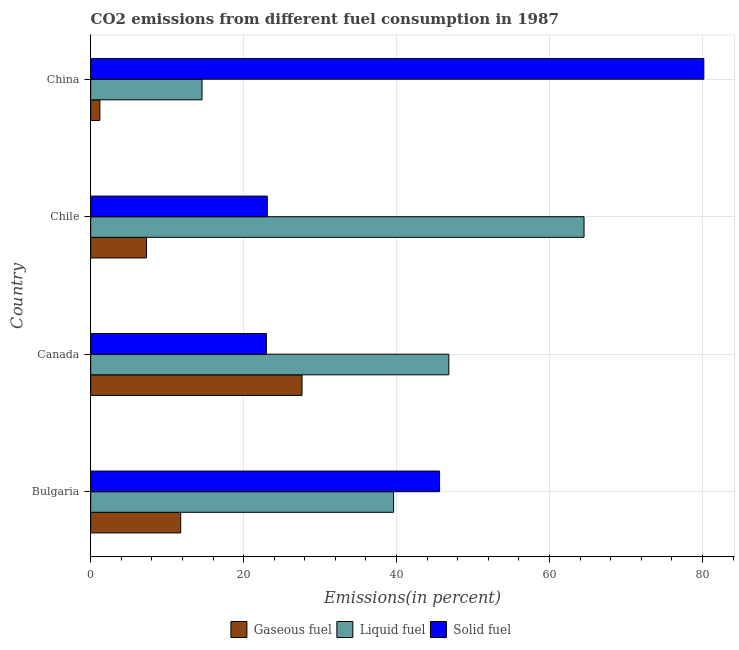Are the number of bars on each tick of the Y-axis equal?
Provide a succinct answer. Yes. How many bars are there on the 2nd tick from the top?
Give a very brief answer. 3. In how many cases, is the number of bars for a given country not equal to the number of legend labels?
Make the answer very short. 0. What is the percentage of solid fuel emission in China?
Provide a succinct answer. 80.18. Across all countries, what is the maximum percentage of solid fuel emission?
Offer a terse response. 80.18. Across all countries, what is the minimum percentage of liquid fuel emission?
Keep it short and to the point. 14.56. In which country was the percentage of solid fuel emission minimum?
Ensure brevity in your answer.  Canada. What is the total percentage of solid fuel emission in the graph?
Offer a terse response. 171.88. What is the difference between the percentage of gaseous fuel emission in Bulgaria and that in Chile?
Provide a short and direct response. 4.48. What is the difference between the percentage of solid fuel emission in China and the percentage of liquid fuel emission in Chile?
Provide a succinct answer. 15.66. What is the average percentage of liquid fuel emission per country?
Give a very brief answer. 41.38. What is the difference between the percentage of gaseous fuel emission and percentage of liquid fuel emission in Canada?
Keep it short and to the point. -19.2. In how many countries, is the percentage of liquid fuel emission greater than 32 %?
Provide a succinct answer. 3. What is the ratio of the percentage of gaseous fuel emission in Bulgaria to that in Chile?
Ensure brevity in your answer.  1.61. Is the percentage of solid fuel emission in Canada less than that in Chile?
Offer a terse response. Yes. What is the difference between the highest and the second highest percentage of gaseous fuel emission?
Provide a succinct answer. 15.86. What is the difference between the highest and the lowest percentage of solid fuel emission?
Keep it short and to the point. 57.2. Is the sum of the percentage of liquid fuel emission in Bulgaria and Chile greater than the maximum percentage of gaseous fuel emission across all countries?
Provide a short and direct response. Yes. What does the 2nd bar from the top in Chile represents?
Keep it short and to the point. Liquid fuel. What does the 2nd bar from the bottom in Chile represents?
Make the answer very short. Liquid fuel. How many bars are there?
Offer a terse response. 12. Are all the bars in the graph horizontal?
Provide a succinct answer. Yes. What is the difference between two consecutive major ticks on the X-axis?
Give a very brief answer. 20. What is the title of the graph?
Your response must be concise. CO2 emissions from different fuel consumption in 1987. What is the label or title of the X-axis?
Your response must be concise. Emissions(in percent). What is the label or title of the Y-axis?
Make the answer very short. Country. What is the Emissions(in percent) of Gaseous fuel in Bulgaria?
Provide a short and direct response. 11.78. What is the Emissions(in percent) in Liquid fuel in Bulgaria?
Your answer should be very brief. 39.61. What is the Emissions(in percent) of Solid fuel in Bulgaria?
Give a very brief answer. 45.62. What is the Emissions(in percent) of Gaseous fuel in Canada?
Make the answer very short. 27.64. What is the Emissions(in percent) in Liquid fuel in Canada?
Ensure brevity in your answer.  46.84. What is the Emissions(in percent) of Solid fuel in Canada?
Make the answer very short. 22.98. What is the Emissions(in percent) in Gaseous fuel in Chile?
Your answer should be compact. 7.29. What is the Emissions(in percent) in Liquid fuel in Chile?
Your answer should be compact. 64.52. What is the Emissions(in percent) of Solid fuel in Chile?
Make the answer very short. 23.1. What is the Emissions(in percent) in Gaseous fuel in China?
Make the answer very short. 1.2. What is the Emissions(in percent) of Liquid fuel in China?
Your response must be concise. 14.56. What is the Emissions(in percent) in Solid fuel in China?
Keep it short and to the point. 80.18. Across all countries, what is the maximum Emissions(in percent) of Gaseous fuel?
Offer a terse response. 27.64. Across all countries, what is the maximum Emissions(in percent) of Liquid fuel?
Keep it short and to the point. 64.52. Across all countries, what is the maximum Emissions(in percent) of Solid fuel?
Provide a succinct answer. 80.18. Across all countries, what is the minimum Emissions(in percent) of Gaseous fuel?
Keep it short and to the point. 1.2. Across all countries, what is the minimum Emissions(in percent) of Liquid fuel?
Your response must be concise. 14.56. Across all countries, what is the minimum Emissions(in percent) in Solid fuel?
Ensure brevity in your answer.  22.98. What is the total Emissions(in percent) in Gaseous fuel in the graph?
Offer a terse response. 47.91. What is the total Emissions(in percent) in Liquid fuel in the graph?
Offer a terse response. 165.53. What is the total Emissions(in percent) in Solid fuel in the graph?
Make the answer very short. 171.88. What is the difference between the Emissions(in percent) in Gaseous fuel in Bulgaria and that in Canada?
Offer a very short reply. -15.86. What is the difference between the Emissions(in percent) in Liquid fuel in Bulgaria and that in Canada?
Keep it short and to the point. -7.22. What is the difference between the Emissions(in percent) in Solid fuel in Bulgaria and that in Canada?
Give a very brief answer. 22.65. What is the difference between the Emissions(in percent) of Gaseous fuel in Bulgaria and that in Chile?
Ensure brevity in your answer.  4.48. What is the difference between the Emissions(in percent) of Liquid fuel in Bulgaria and that in Chile?
Provide a short and direct response. -24.9. What is the difference between the Emissions(in percent) of Solid fuel in Bulgaria and that in Chile?
Your answer should be compact. 22.53. What is the difference between the Emissions(in percent) of Gaseous fuel in Bulgaria and that in China?
Offer a terse response. 10.57. What is the difference between the Emissions(in percent) in Liquid fuel in Bulgaria and that in China?
Your answer should be compact. 25.05. What is the difference between the Emissions(in percent) in Solid fuel in Bulgaria and that in China?
Provide a short and direct response. -34.55. What is the difference between the Emissions(in percent) of Gaseous fuel in Canada and that in Chile?
Give a very brief answer. 20.34. What is the difference between the Emissions(in percent) in Liquid fuel in Canada and that in Chile?
Your response must be concise. -17.68. What is the difference between the Emissions(in percent) in Solid fuel in Canada and that in Chile?
Provide a succinct answer. -0.12. What is the difference between the Emissions(in percent) in Gaseous fuel in Canada and that in China?
Keep it short and to the point. 26.43. What is the difference between the Emissions(in percent) of Liquid fuel in Canada and that in China?
Offer a terse response. 32.27. What is the difference between the Emissions(in percent) of Solid fuel in Canada and that in China?
Your response must be concise. -57.2. What is the difference between the Emissions(in percent) in Gaseous fuel in Chile and that in China?
Your answer should be very brief. 6.09. What is the difference between the Emissions(in percent) of Liquid fuel in Chile and that in China?
Ensure brevity in your answer.  49.95. What is the difference between the Emissions(in percent) in Solid fuel in Chile and that in China?
Provide a succinct answer. -57.08. What is the difference between the Emissions(in percent) in Gaseous fuel in Bulgaria and the Emissions(in percent) in Liquid fuel in Canada?
Provide a succinct answer. -35.06. What is the difference between the Emissions(in percent) of Gaseous fuel in Bulgaria and the Emissions(in percent) of Solid fuel in Canada?
Provide a succinct answer. -11.2. What is the difference between the Emissions(in percent) in Liquid fuel in Bulgaria and the Emissions(in percent) in Solid fuel in Canada?
Keep it short and to the point. 16.64. What is the difference between the Emissions(in percent) of Gaseous fuel in Bulgaria and the Emissions(in percent) of Liquid fuel in Chile?
Provide a succinct answer. -52.74. What is the difference between the Emissions(in percent) in Gaseous fuel in Bulgaria and the Emissions(in percent) in Solid fuel in Chile?
Offer a terse response. -11.32. What is the difference between the Emissions(in percent) of Liquid fuel in Bulgaria and the Emissions(in percent) of Solid fuel in Chile?
Provide a succinct answer. 16.52. What is the difference between the Emissions(in percent) in Gaseous fuel in Bulgaria and the Emissions(in percent) in Liquid fuel in China?
Offer a terse response. -2.79. What is the difference between the Emissions(in percent) of Gaseous fuel in Bulgaria and the Emissions(in percent) of Solid fuel in China?
Your answer should be compact. -68.4. What is the difference between the Emissions(in percent) in Liquid fuel in Bulgaria and the Emissions(in percent) in Solid fuel in China?
Offer a very short reply. -40.57. What is the difference between the Emissions(in percent) in Gaseous fuel in Canada and the Emissions(in percent) in Liquid fuel in Chile?
Provide a succinct answer. -36.88. What is the difference between the Emissions(in percent) of Gaseous fuel in Canada and the Emissions(in percent) of Solid fuel in Chile?
Keep it short and to the point. 4.54. What is the difference between the Emissions(in percent) of Liquid fuel in Canada and the Emissions(in percent) of Solid fuel in Chile?
Your answer should be very brief. 23.74. What is the difference between the Emissions(in percent) in Gaseous fuel in Canada and the Emissions(in percent) in Liquid fuel in China?
Your response must be concise. 13.08. What is the difference between the Emissions(in percent) in Gaseous fuel in Canada and the Emissions(in percent) in Solid fuel in China?
Your answer should be compact. -52.54. What is the difference between the Emissions(in percent) of Liquid fuel in Canada and the Emissions(in percent) of Solid fuel in China?
Keep it short and to the point. -33.34. What is the difference between the Emissions(in percent) in Gaseous fuel in Chile and the Emissions(in percent) in Liquid fuel in China?
Keep it short and to the point. -7.27. What is the difference between the Emissions(in percent) of Gaseous fuel in Chile and the Emissions(in percent) of Solid fuel in China?
Provide a succinct answer. -72.88. What is the difference between the Emissions(in percent) in Liquid fuel in Chile and the Emissions(in percent) in Solid fuel in China?
Keep it short and to the point. -15.66. What is the average Emissions(in percent) in Gaseous fuel per country?
Keep it short and to the point. 11.98. What is the average Emissions(in percent) in Liquid fuel per country?
Provide a short and direct response. 41.38. What is the average Emissions(in percent) of Solid fuel per country?
Your answer should be very brief. 42.97. What is the difference between the Emissions(in percent) in Gaseous fuel and Emissions(in percent) in Liquid fuel in Bulgaria?
Your answer should be compact. -27.84. What is the difference between the Emissions(in percent) of Gaseous fuel and Emissions(in percent) of Solid fuel in Bulgaria?
Keep it short and to the point. -33.85. What is the difference between the Emissions(in percent) of Liquid fuel and Emissions(in percent) of Solid fuel in Bulgaria?
Provide a short and direct response. -6.01. What is the difference between the Emissions(in percent) in Gaseous fuel and Emissions(in percent) in Liquid fuel in Canada?
Provide a succinct answer. -19.2. What is the difference between the Emissions(in percent) in Gaseous fuel and Emissions(in percent) in Solid fuel in Canada?
Your answer should be very brief. 4.66. What is the difference between the Emissions(in percent) of Liquid fuel and Emissions(in percent) of Solid fuel in Canada?
Your response must be concise. 23.86. What is the difference between the Emissions(in percent) in Gaseous fuel and Emissions(in percent) in Liquid fuel in Chile?
Offer a very short reply. -57.22. What is the difference between the Emissions(in percent) of Gaseous fuel and Emissions(in percent) of Solid fuel in Chile?
Provide a short and direct response. -15.8. What is the difference between the Emissions(in percent) of Liquid fuel and Emissions(in percent) of Solid fuel in Chile?
Make the answer very short. 41.42. What is the difference between the Emissions(in percent) of Gaseous fuel and Emissions(in percent) of Liquid fuel in China?
Offer a very short reply. -13.36. What is the difference between the Emissions(in percent) in Gaseous fuel and Emissions(in percent) in Solid fuel in China?
Your response must be concise. -78.97. What is the difference between the Emissions(in percent) of Liquid fuel and Emissions(in percent) of Solid fuel in China?
Provide a succinct answer. -65.62. What is the ratio of the Emissions(in percent) of Gaseous fuel in Bulgaria to that in Canada?
Keep it short and to the point. 0.43. What is the ratio of the Emissions(in percent) of Liquid fuel in Bulgaria to that in Canada?
Offer a terse response. 0.85. What is the ratio of the Emissions(in percent) of Solid fuel in Bulgaria to that in Canada?
Ensure brevity in your answer.  1.99. What is the ratio of the Emissions(in percent) of Gaseous fuel in Bulgaria to that in Chile?
Provide a short and direct response. 1.61. What is the ratio of the Emissions(in percent) in Liquid fuel in Bulgaria to that in Chile?
Your answer should be very brief. 0.61. What is the ratio of the Emissions(in percent) in Solid fuel in Bulgaria to that in Chile?
Offer a very short reply. 1.98. What is the ratio of the Emissions(in percent) of Gaseous fuel in Bulgaria to that in China?
Offer a terse response. 9.78. What is the ratio of the Emissions(in percent) in Liquid fuel in Bulgaria to that in China?
Offer a terse response. 2.72. What is the ratio of the Emissions(in percent) of Solid fuel in Bulgaria to that in China?
Provide a succinct answer. 0.57. What is the ratio of the Emissions(in percent) in Gaseous fuel in Canada to that in Chile?
Your response must be concise. 3.79. What is the ratio of the Emissions(in percent) of Liquid fuel in Canada to that in Chile?
Provide a short and direct response. 0.73. What is the ratio of the Emissions(in percent) of Solid fuel in Canada to that in Chile?
Offer a very short reply. 0.99. What is the ratio of the Emissions(in percent) of Gaseous fuel in Canada to that in China?
Provide a short and direct response. 22.94. What is the ratio of the Emissions(in percent) in Liquid fuel in Canada to that in China?
Your answer should be compact. 3.22. What is the ratio of the Emissions(in percent) in Solid fuel in Canada to that in China?
Your response must be concise. 0.29. What is the ratio of the Emissions(in percent) of Gaseous fuel in Chile to that in China?
Keep it short and to the point. 6.05. What is the ratio of the Emissions(in percent) in Liquid fuel in Chile to that in China?
Offer a very short reply. 4.43. What is the ratio of the Emissions(in percent) of Solid fuel in Chile to that in China?
Your response must be concise. 0.29. What is the difference between the highest and the second highest Emissions(in percent) in Gaseous fuel?
Offer a terse response. 15.86. What is the difference between the highest and the second highest Emissions(in percent) of Liquid fuel?
Offer a terse response. 17.68. What is the difference between the highest and the second highest Emissions(in percent) in Solid fuel?
Provide a short and direct response. 34.55. What is the difference between the highest and the lowest Emissions(in percent) of Gaseous fuel?
Offer a very short reply. 26.43. What is the difference between the highest and the lowest Emissions(in percent) in Liquid fuel?
Your response must be concise. 49.95. What is the difference between the highest and the lowest Emissions(in percent) in Solid fuel?
Offer a very short reply. 57.2. 